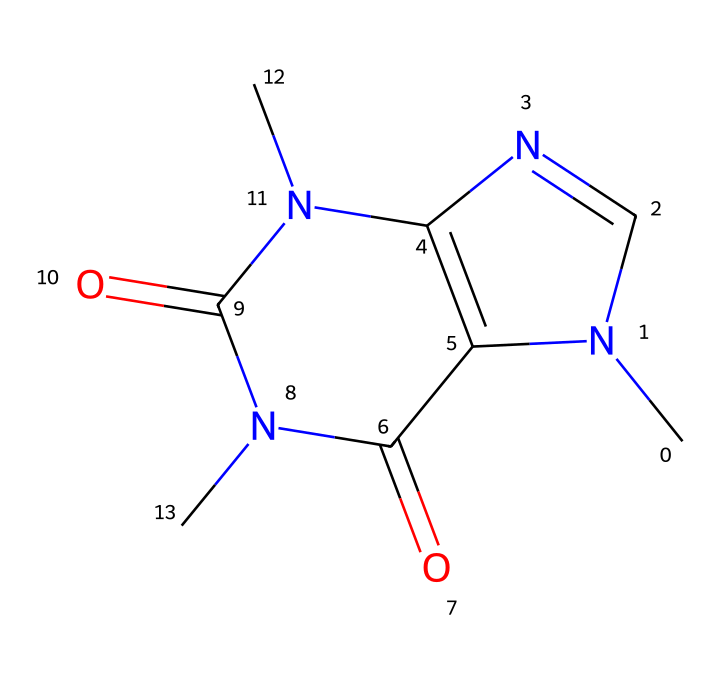how many rings are in the caffeine structure? The SMILES representation indicates two interconnected rings; one is a five-membered ring containing nitrogen atoms, and the other is a six-membered ring, making a total of two rings in the structure.
Answer: two what type of heteroatoms are present in the caffeine molecule? The structure contains nitrogen (N) and oxygen (O) as heteroatoms, which are commonly found in coordination compounds. There are three nitrogen atoms and two oxygen atoms present in the structure.
Answer: nitrogen, oxygen how many carbon atoms are there in the caffeine molecule? By analyzing the SMILES representation, we identify five carbon (C) atoms within the chemical structure, following typical bonding configurations and connections indicated in the representation.
Answer: five which functional groups are present in the caffeine structure? The caffeine molecule features amide and imine functional groups as indicated by the presence of carbonyl groups (C=O) connected to nitrogen atoms, typical of amides, and the nitrogen in the ring contributes to the imine character.
Answer: amide, imine what is the chemical formula of caffeine based on its structure? Counting the total of each type of atom in the SMILES representation gives us C8H10N4O2, summarizing the composition of the caffeine molecule effectively.
Answer: C8H10N4O2 